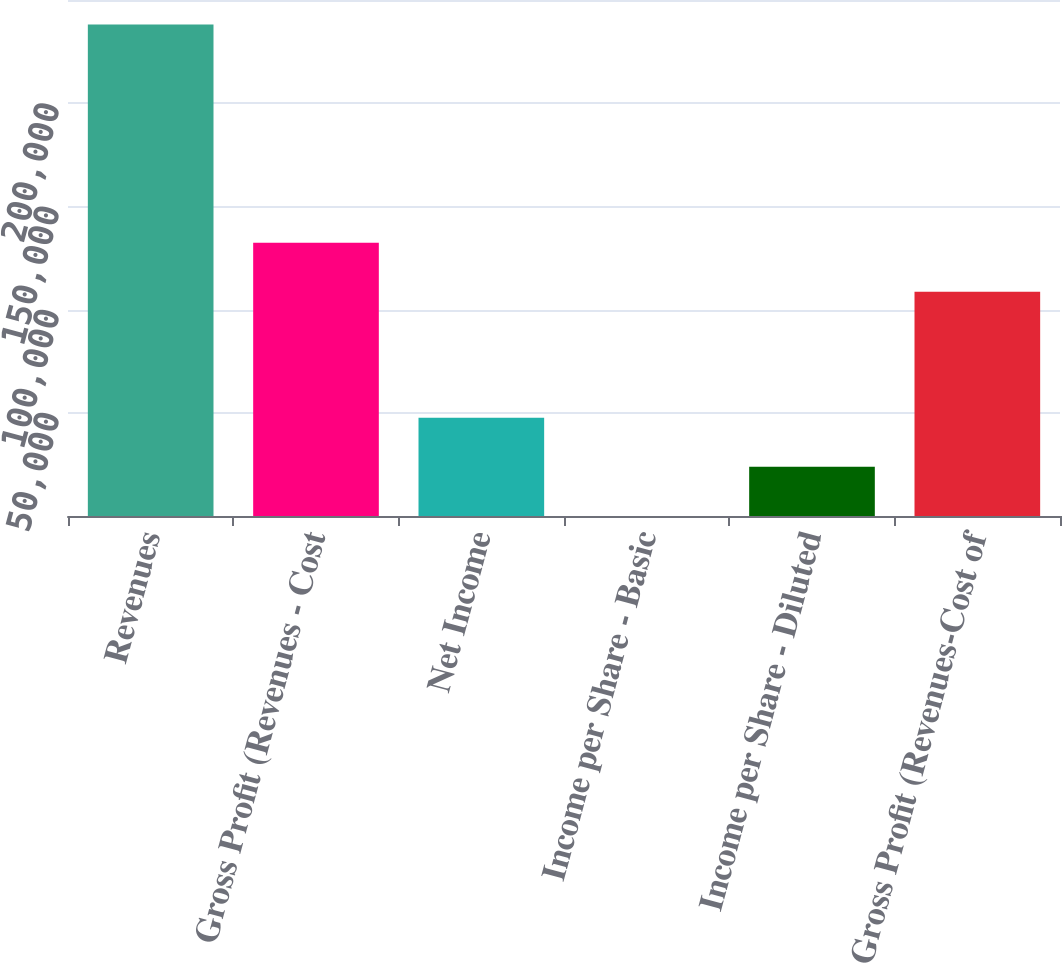<chart> <loc_0><loc_0><loc_500><loc_500><bar_chart><fcel>Revenues<fcel>Gross Profit (Revenues - Cost<fcel>Net Income<fcel>Income per Share - Basic<fcel>Income per Share - Diluted<fcel>Gross Profit (Revenues-Cost of<nl><fcel>238116<fcel>132422<fcel>47623.3<fcel>0.19<fcel>23811.8<fcel>108610<nl></chart> 